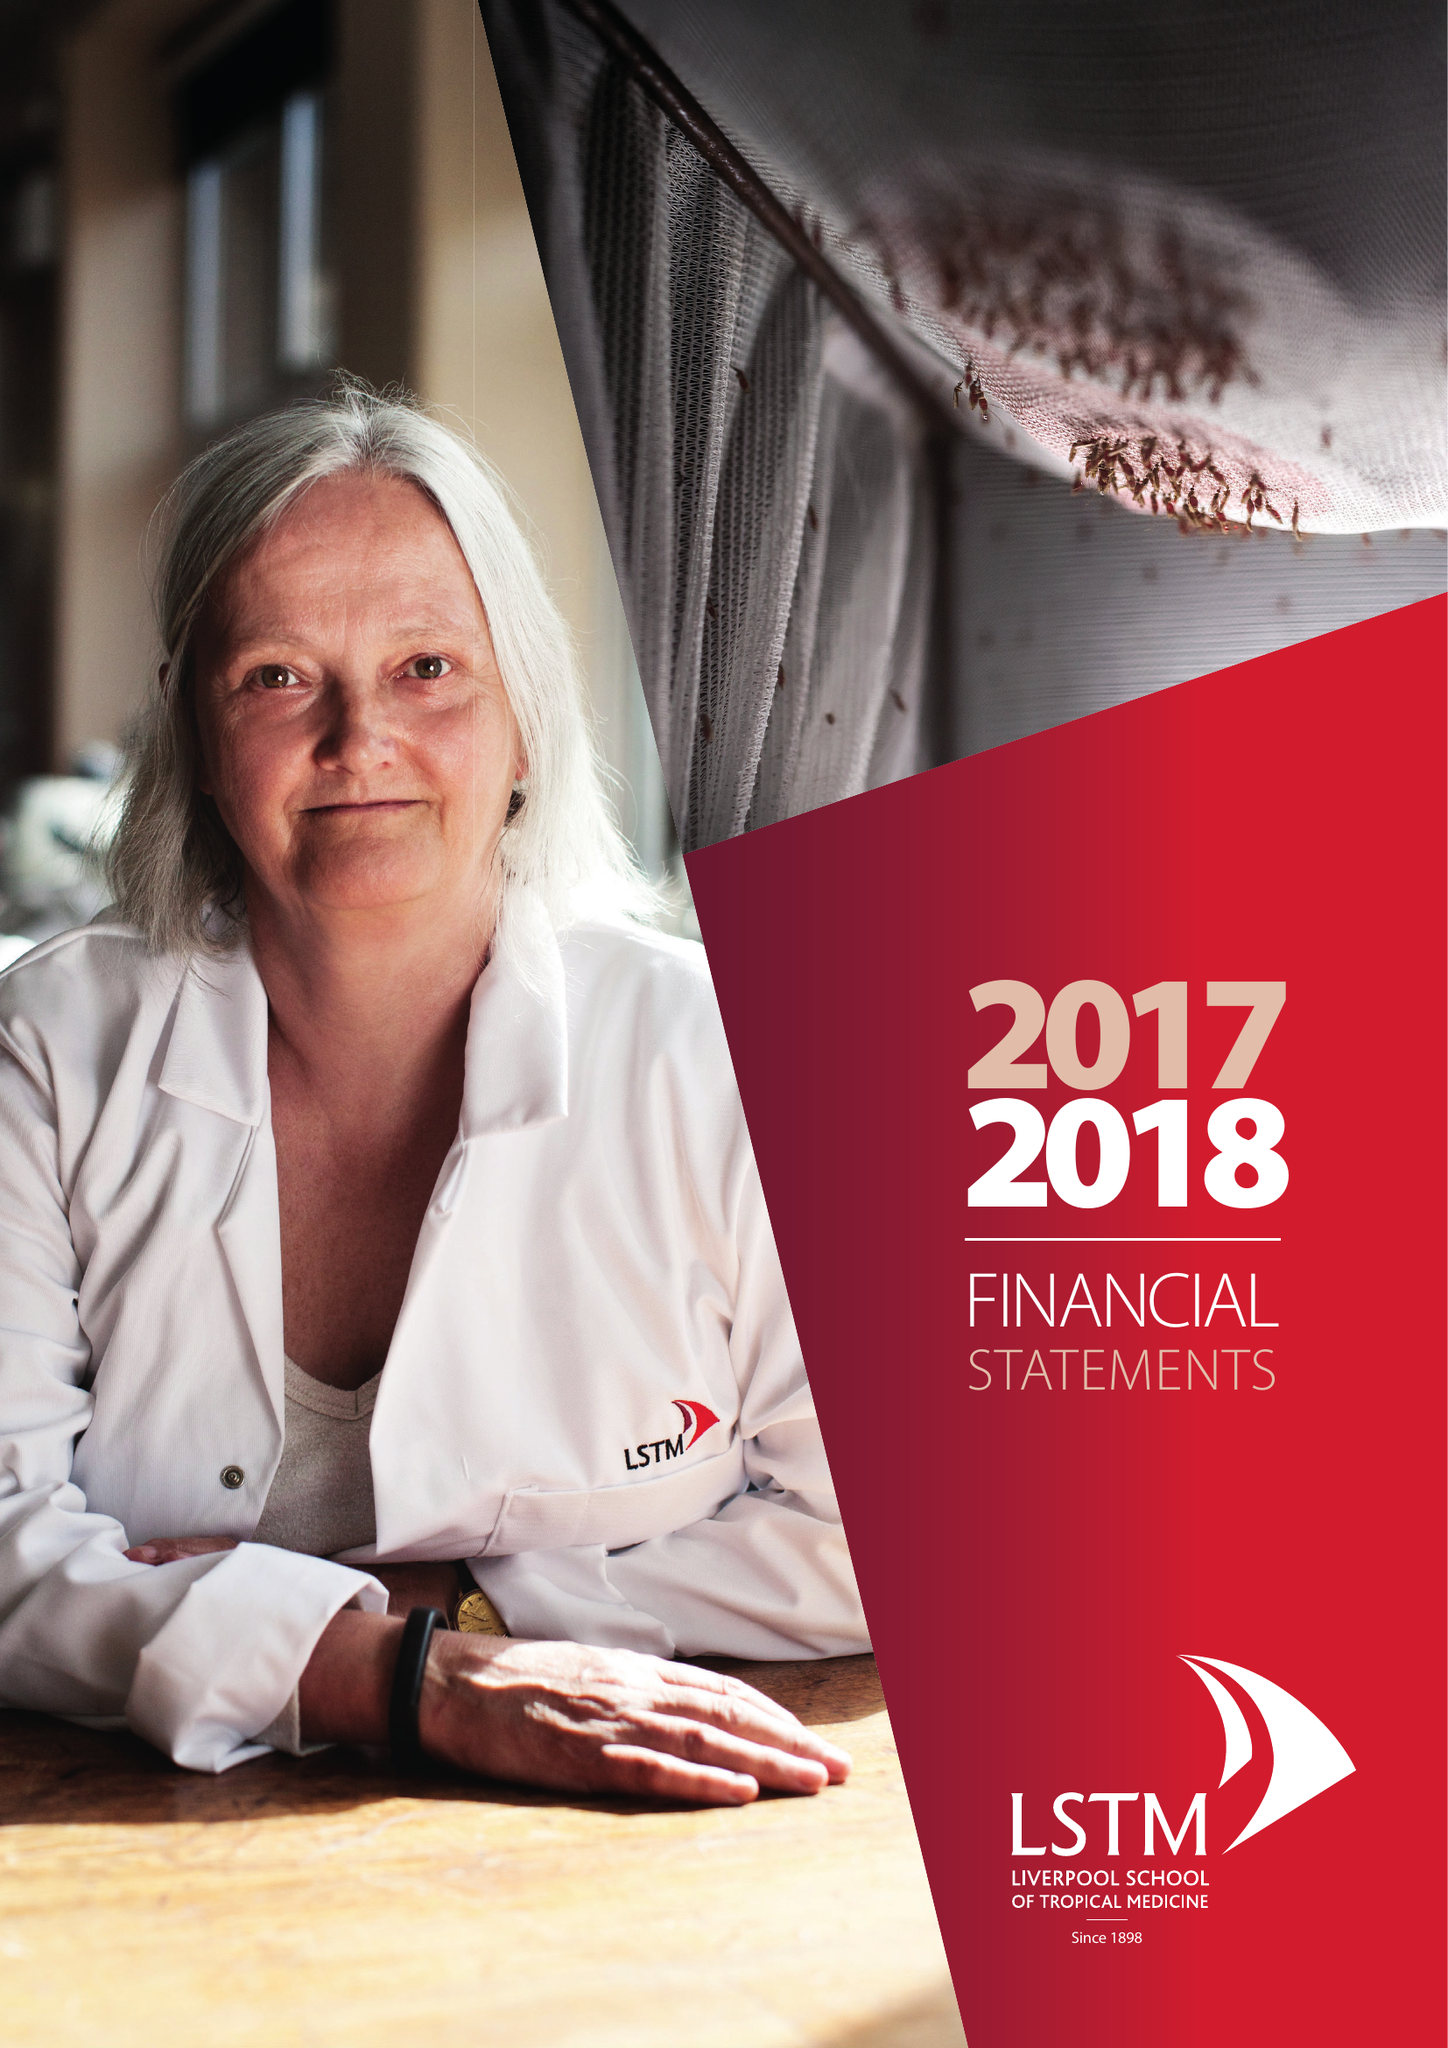What is the value for the address__post_town?
Answer the question using a single word or phrase. LIVERPOOL 